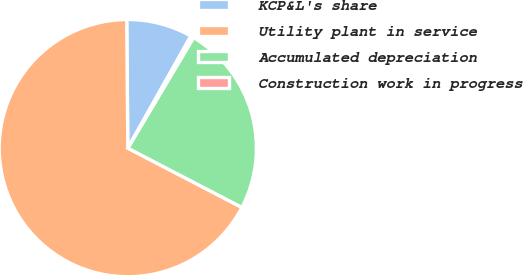Convert chart. <chart><loc_0><loc_0><loc_500><loc_500><pie_chart><fcel>KCP&L's share<fcel>Utility plant in service<fcel>Accumulated depreciation<fcel>Construction work in progress<nl><fcel>8.29%<fcel>67.24%<fcel>24.08%<fcel>0.39%<nl></chart> 